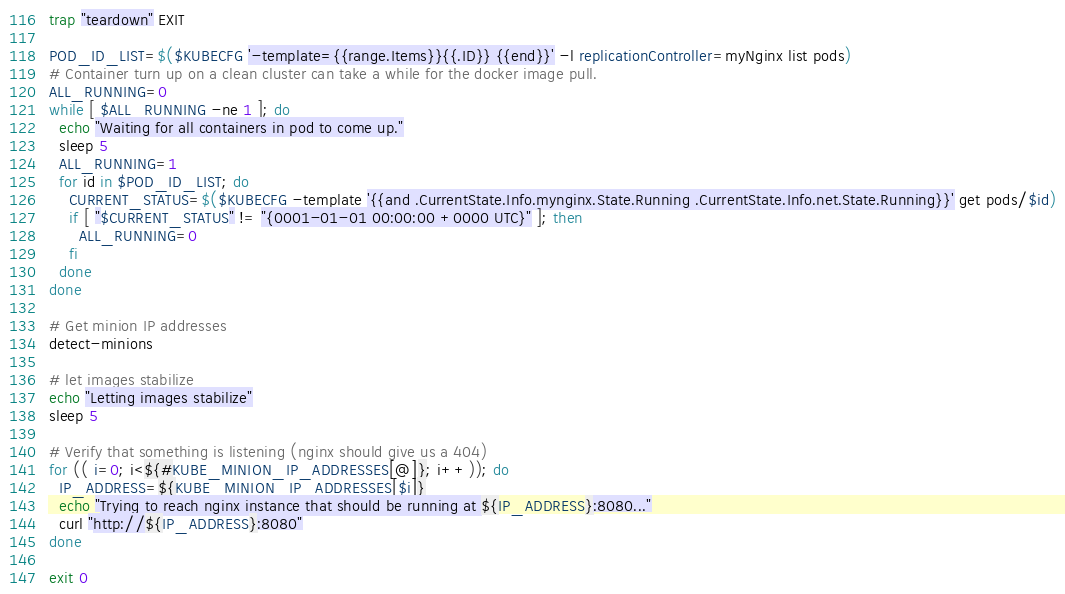<code> <loc_0><loc_0><loc_500><loc_500><_Bash_>
trap "teardown" EXIT

POD_ID_LIST=$($KUBECFG '-template={{range.Items}}{{.ID}} {{end}}' -l replicationController=myNginx list pods)
# Container turn up on a clean cluster can take a while for the docker image pull.
ALL_RUNNING=0
while [ $ALL_RUNNING -ne 1 ]; do
  echo "Waiting for all containers in pod to come up."
  sleep 5
  ALL_RUNNING=1
  for id in $POD_ID_LIST; do
    CURRENT_STATUS=$($KUBECFG -template '{{and .CurrentState.Info.mynginx.State.Running .CurrentState.Info.net.State.Running}}' get pods/$id)
    if [ "$CURRENT_STATUS" != "{0001-01-01 00:00:00 +0000 UTC}" ]; then
      ALL_RUNNING=0
    fi
  done
done

# Get minion IP addresses
detect-minions

# let images stabilize
echo "Letting images stabilize"
sleep 5

# Verify that something is listening (nginx should give us a 404)
for (( i=0; i<${#KUBE_MINION_IP_ADDRESSES[@]}; i++)); do
  IP_ADDRESS=${KUBE_MINION_IP_ADDRESSES[$i]}
  echo "Trying to reach nginx instance that should be running at ${IP_ADDRESS}:8080..."
  curl "http://${IP_ADDRESS}:8080"
done

exit 0
</code> 